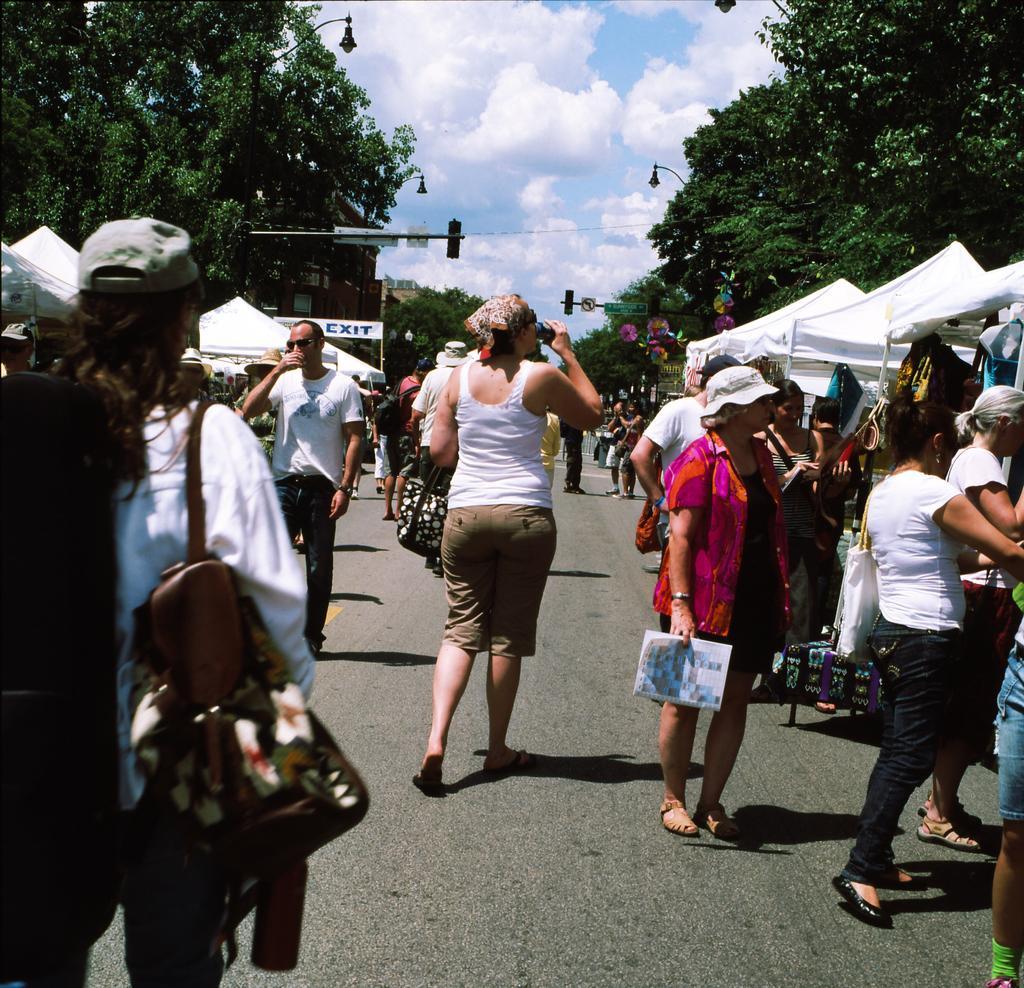Describe this image in one or two sentences. In this picture we can see many people standing on the road with trees on either side. Here the sky is blue. 